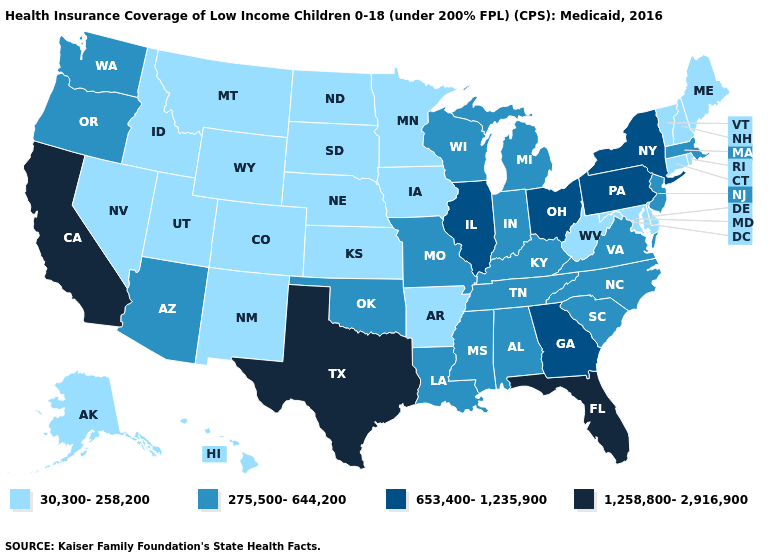Name the states that have a value in the range 653,400-1,235,900?
Answer briefly. Georgia, Illinois, New York, Ohio, Pennsylvania. How many symbols are there in the legend?
Answer briefly. 4. Does California have the highest value in the USA?
Be succinct. Yes. What is the value of Mississippi?
Quick response, please. 275,500-644,200. Name the states that have a value in the range 653,400-1,235,900?
Write a very short answer. Georgia, Illinois, New York, Ohio, Pennsylvania. What is the value of Oregon?
Answer briefly. 275,500-644,200. Among the states that border Michigan , which have the highest value?
Write a very short answer. Ohio. Name the states that have a value in the range 1,258,800-2,916,900?
Concise answer only. California, Florida, Texas. Name the states that have a value in the range 653,400-1,235,900?
Quick response, please. Georgia, Illinois, New York, Ohio, Pennsylvania. Does the first symbol in the legend represent the smallest category?
Quick response, please. Yes. Name the states that have a value in the range 1,258,800-2,916,900?
Give a very brief answer. California, Florida, Texas. Name the states that have a value in the range 1,258,800-2,916,900?
Give a very brief answer. California, Florida, Texas. Does New Jersey have the lowest value in the USA?
Keep it brief. No. What is the lowest value in the USA?
Give a very brief answer. 30,300-258,200. Does North Dakota have the highest value in the USA?
Concise answer only. No. 